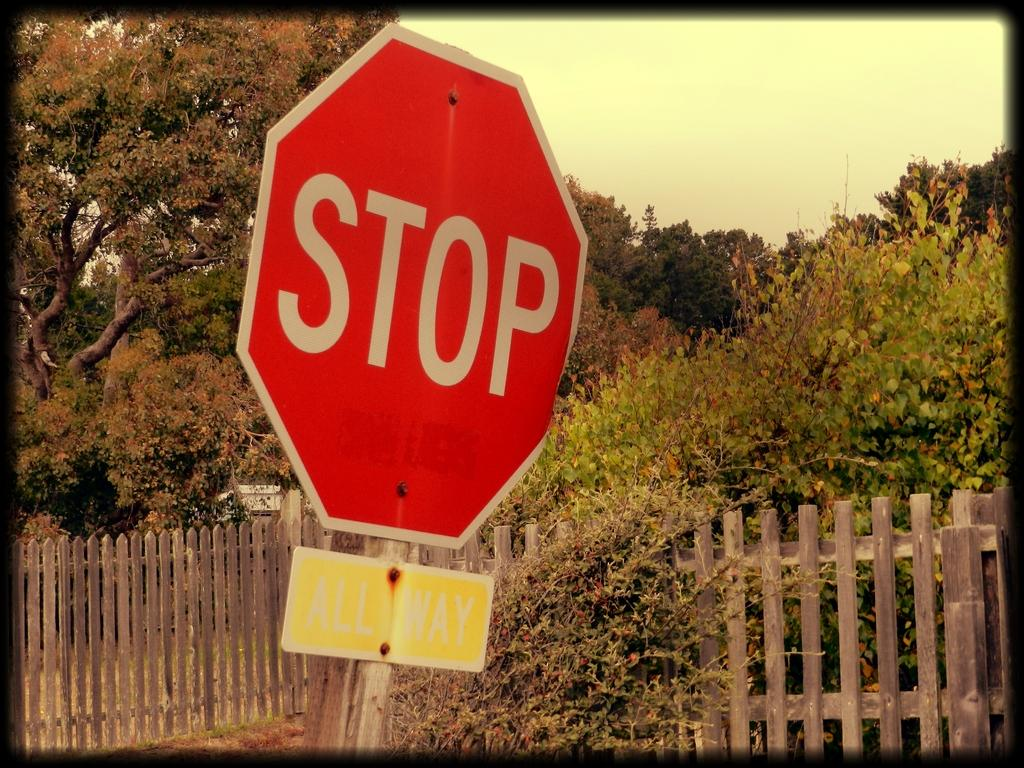<image>
Summarize the visual content of the image. The yellow sign under the red stop sign says ALL WAY. 